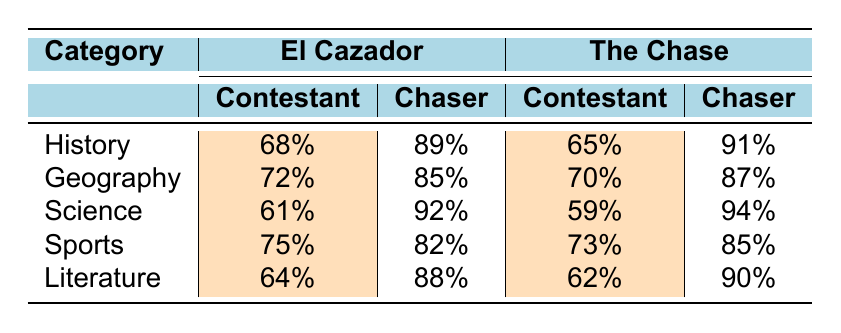What is the contestant success rate for Science in El Cazador? The table shows that under the category "Science" for El Cazador, the contestant success rate is directly listed as 61%.
Answer: 61% Which show has a higher chaser success rate in Geography? In the Geography category, El Cazador has a chaser success rate of 85%, while The Chase has a chaser success rate of 87%. The Chase has a higher rate.
Answer: The Chase What is the difference in the contestant success rates for History between the two shows? From the table, El Cazador has a contestant success rate of 68% in History, and The Chase has a success rate of 65%. The difference is 68% - 65% = 3%.
Answer: 3% Is it true that the contestant success rate in Sports is higher for El Cazador than for The Chase? Looking at the Sports category, El Cazador has a contestant success rate of 75%, while The Chase has a contestant success rate of 73%. Since 75% is greater than 73%, the statement is true.
Answer: Yes What is the average contestant success rate across all categories for The Chase? For The Chase, the contestant success rates are 65%, 70%, 59%, 73%, and 62%. First, sum these values: 65 + 70 + 59 + 73 + 62 = 329. Now divide by 5 categories: 329 / 5 = 65.8%.
Answer: 65.8% 